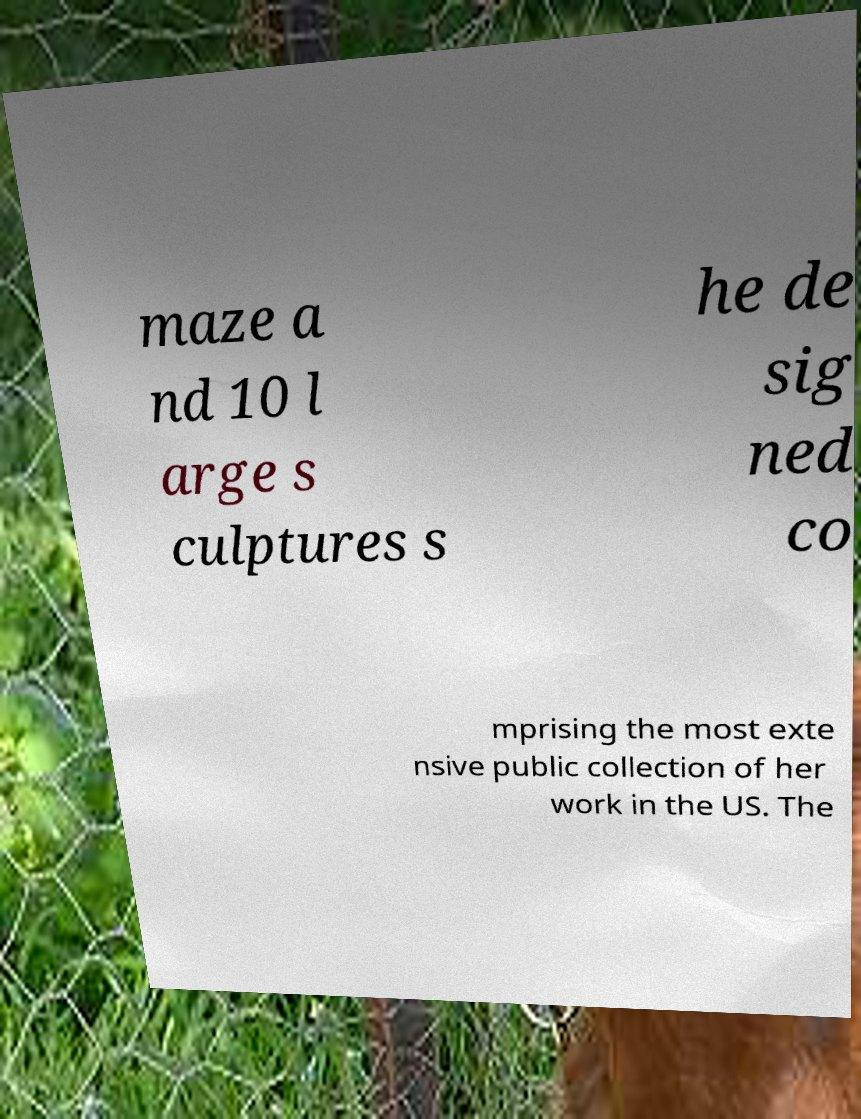What messages or text are displayed in this image? I need them in a readable, typed format. maze a nd 10 l arge s culptures s he de sig ned co mprising the most exte nsive public collection of her work in the US. The 